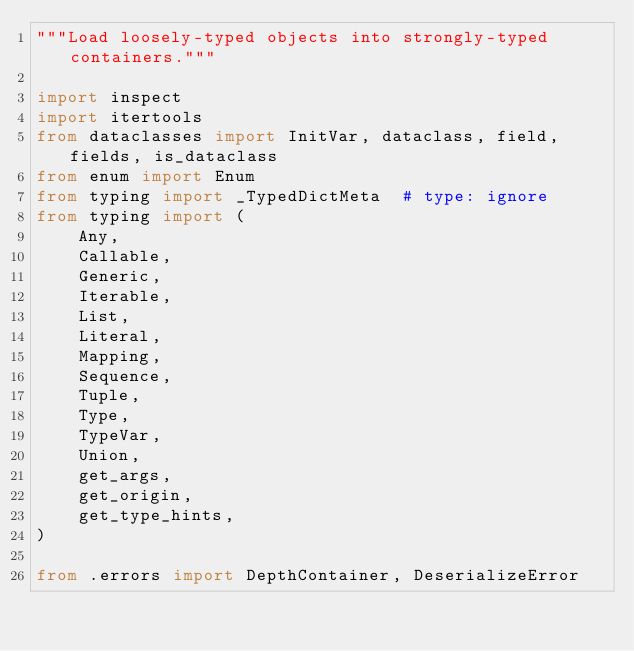<code> <loc_0><loc_0><loc_500><loc_500><_Python_>"""Load loosely-typed objects into strongly-typed containers."""

import inspect
import itertools
from dataclasses import InitVar, dataclass, field, fields, is_dataclass
from enum import Enum
from typing import _TypedDictMeta  # type: ignore
from typing import (
    Any,
    Callable,
    Generic,
    Iterable,
    List,
    Literal,
    Mapping,
    Sequence,
    Tuple,
    Type,
    TypeVar,
    Union,
    get_args,
    get_origin,
    get_type_hints,
)

from .errors import DepthContainer, DeserializeError</code> 